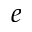Convert formula to latex. <formula><loc_0><loc_0><loc_500><loc_500>e</formula> 